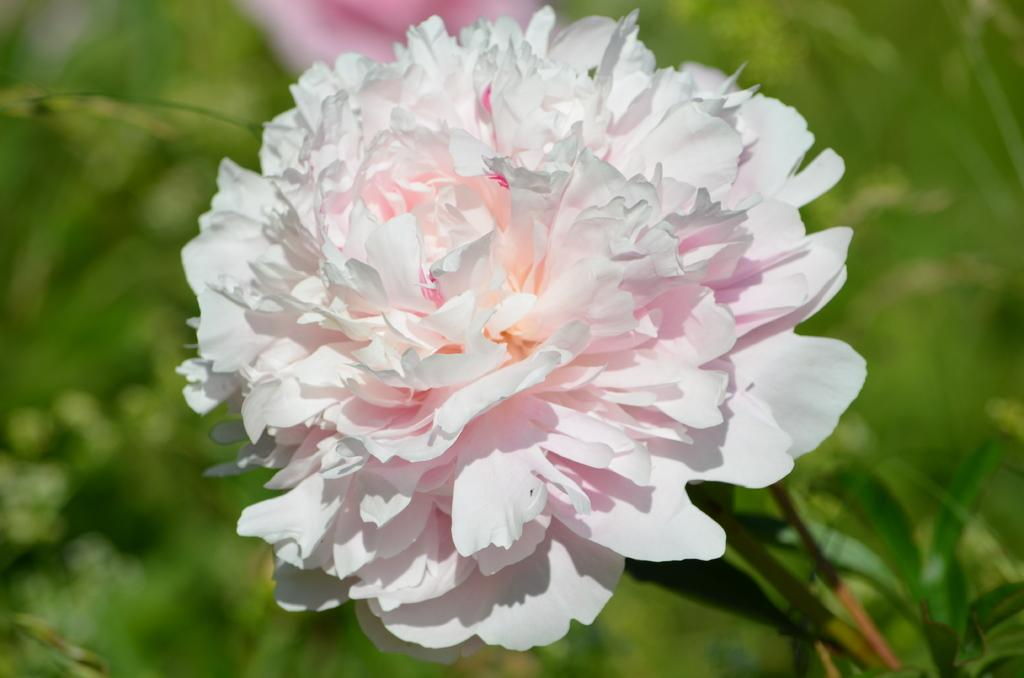What is the main subject of the image? There is a flower in the center of the image. Can you describe the flower in the image? Unfortunately, the facts provided do not give any details about the flower's appearance. Is there anything else in the image besides the flower? The facts provided do not mention any other objects or subjects in the image. What type of robin can be seen using the flower in the image? There is no robin present in the image, and the flower is not being used by any animal or person. 